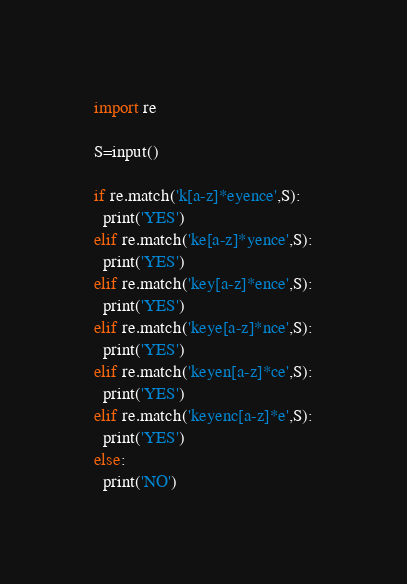Convert code to text. <code><loc_0><loc_0><loc_500><loc_500><_Python_>import re

S=input()

if re.match('k[a-z]*eyence',S):
  print('YES')
elif re.match('ke[a-z]*yence',S):
  print('YES')
elif re.match('key[a-z]*ence',S):
  print('YES')
elif re.match('keye[a-z]*nce',S):
  print('YES')
elif re.match('keyen[a-z]*ce',S):
  print('YES')
elif re.match('keyenc[a-z]*e',S):
  print('YES')
else:
  print('NO')</code> 